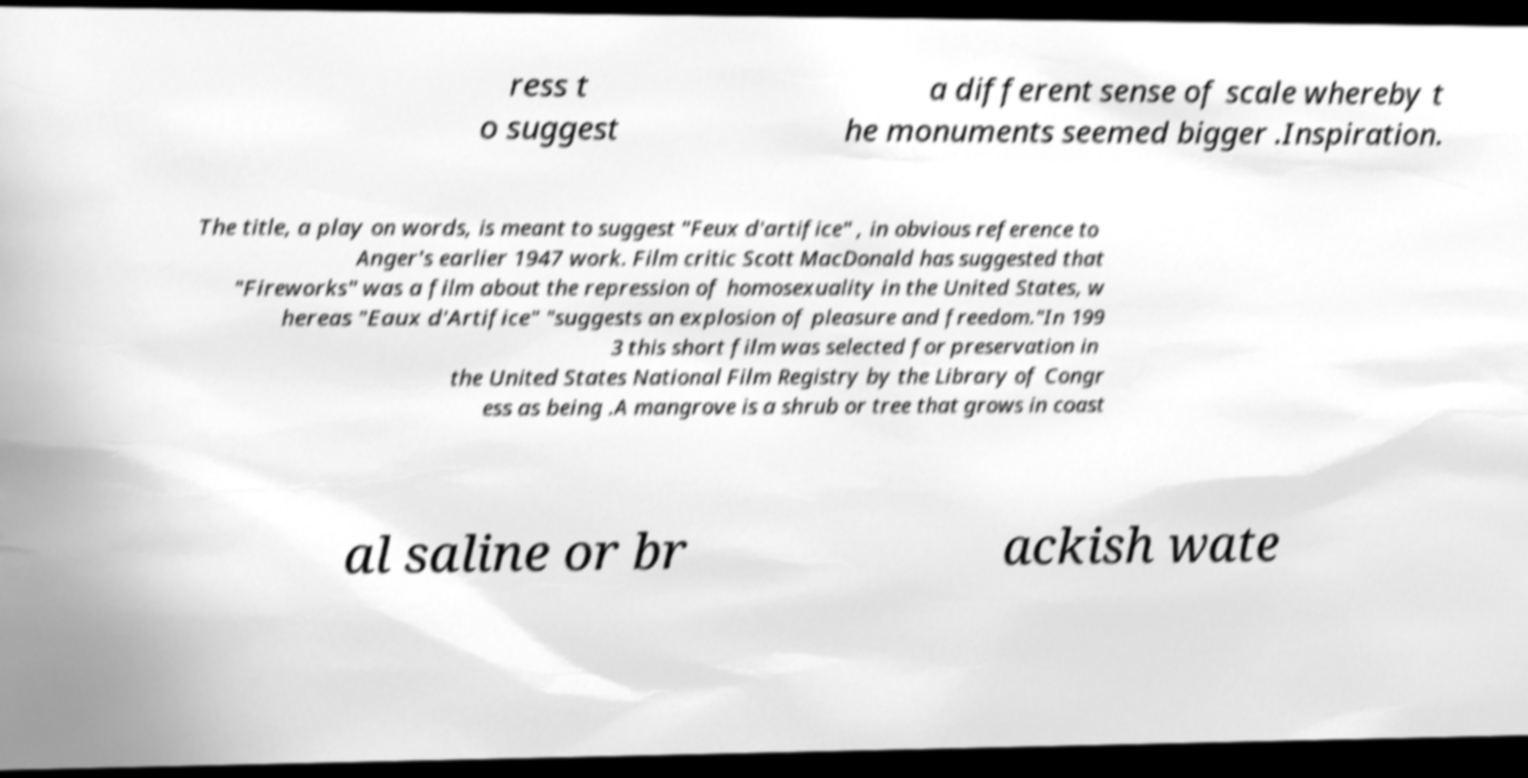What messages or text are displayed in this image? I need them in a readable, typed format. ress t o suggest a different sense of scale whereby t he monuments seemed bigger .Inspiration. The title, a play on words, is meant to suggest "Feux d'artifice" , in obvious reference to Anger's earlier 1947 work. Film critic Scott MacDonald has suggested that "Fireworks" was a film about the repression of homosexuality in the United States, w hereas "Eaux d'Artifice" "suggests an explosion of pleasure and freedom."In 199 3 this short film was selected for preservation in the United States National Film Registry by the Library of Congr ess as being .A mangrove is a shrub or tree that grows in coast al saline or br ackish wate 